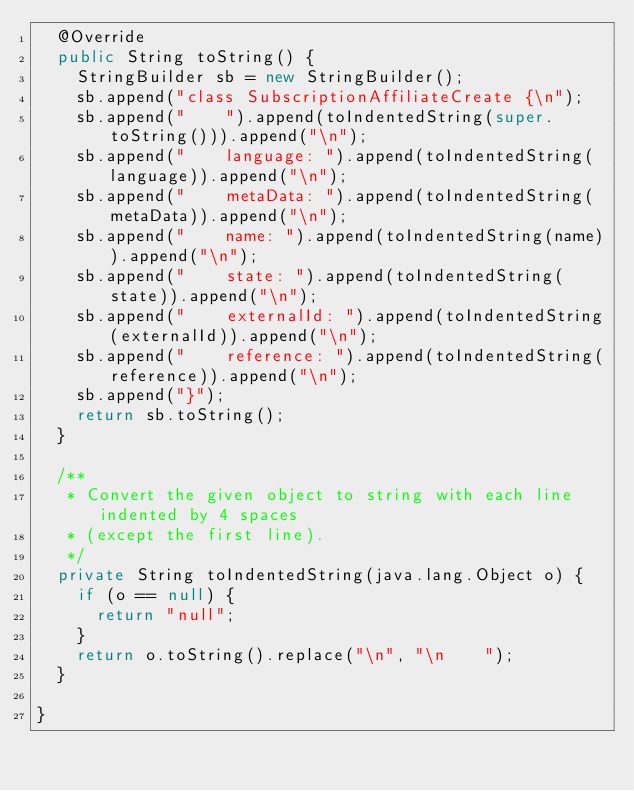Convert code to text. <code><loc_0><loc_0><loc_500><loc_500><_Java_>  @Override
  public String toString() {
    StringBuilder sb = new StringBuilder();
    sb.append("class SubscriptionAffiliateCreate {\n");
    sb.append("    ").append(toIndentedString(super.toString())).append("\n");
    sb.append("    language: ").append(toIndentedString(language)).append("\n");
    sb.append("    metaData: ").append(toIndentedString(metaData)).append("\n");
    sb.append("    name: ").append(toIndentedString(name)).append("\n");
    sb.append("    state: ").append(toIndentedString(state)).append("\n");
    sb.append("    externalId: ").append(toIndentedString(externalId)).append("\n");
    sb.append("    reference: ").append(toIndentedString(reference)).append("\n");
    sb.append("}");
    return sb.toString();
  }

  /**
   * Convert the given object to string with each line indented by 4 spaces
   * (except the first line).
   */
  private String toIndentedString(java.lang.Object o) {
    if (o == null) {
      return "null";
    }
    return o.toString().replace("\n", "\n    ");
  }

}

</code> 